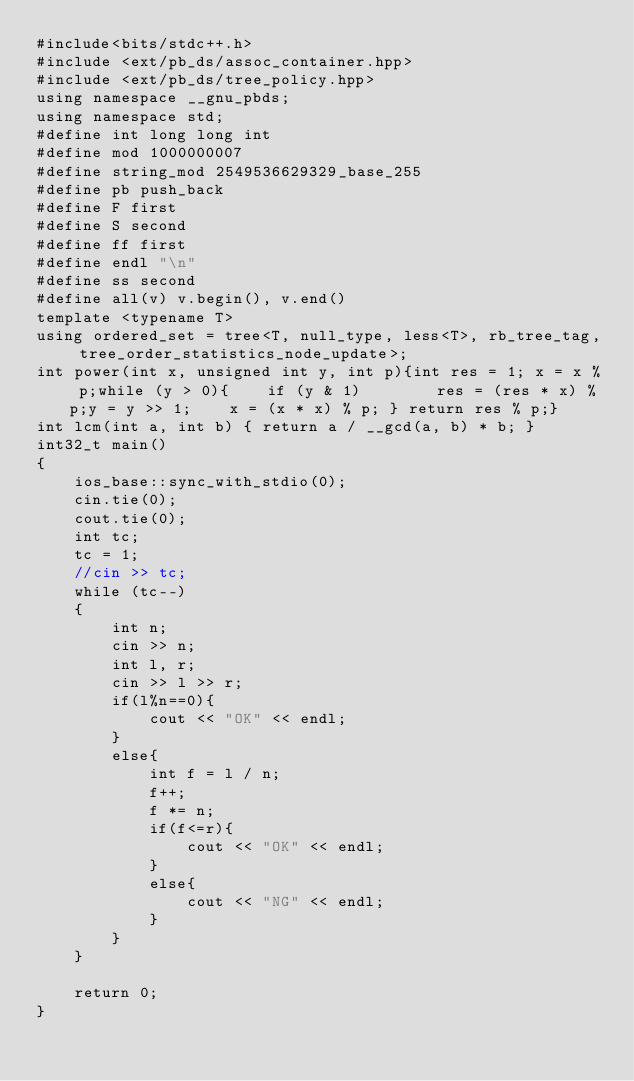<code> <loc_0><loc_0><loc_500><loc_500><_C++_>#include<bits/stdc++.h>
#include <ext/pb_ds/assoc_container.hpp>
#include <ext/pb_ds/tree_policy.hpp>
using namespace __gnu_pbds;
using namespace std;
#define int long long int
#define mod 1000000007
#define string_mod 2549536629329_base_255
#define pb push_back
#define F first
#define S second
#define ff first
#define endl "\n"
#define ss second
#define all(v) v.begin(), v.end()
template <typename T>
using ordered_set = tree<T, null_type, less<T>, rb_tree_tag, tree_order_statistics_node_update>;
int power(int x, unsigned int y, int p){int res = 1; x = x % p;while (y > 0){    if (y & 1)        res = (res * x) % p;y = y >> 1;    x = (x * x) % p; } return res % p;}
int lcm(int a, int b) { return a / __gcd(a, b) * b; }
int32_t main()
{
    ios_base::sync_with_stdio(0);
    cin.tie(0);
    cout.tie(0);
    int tc;
    tc = 1;
    //cin >> tc;
    while (tc--)
    {
        int n;
        cin >> n;
        int l, r;
        cin >> l >> r;
        if(l%n==0){
            cout << "OK" << endl;
        }
        else{
            int f = l / n;
            f++;
            f *= n;
            if(f<=r){
                cout << "OK" << endl;
            }
            else{
                cout << "NG" << endl;
            }
        }
    }

    return 0;
}</code> 